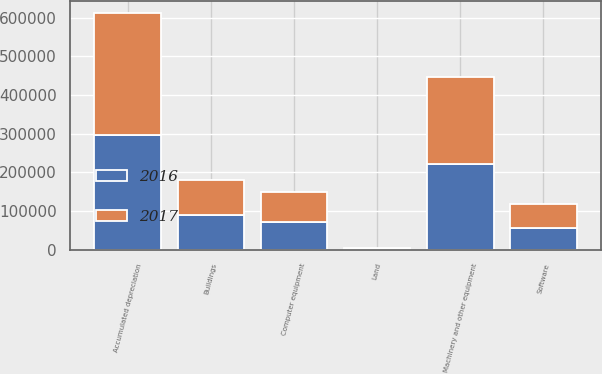Convert chart to OTSL. <chart><loc_0><loc_0><loc_500><loc_500><stacked_bar_chart><ecel><fcel>Land<fcel>Buildings<fcel>Machinery and other equipment<fcel>Computer equipment<fcel>Software<fcel>Accumulated depreciation<nl><fcel>2017<fcel>2471<fcel>90683<fcel>226320<fcel>77508<fcel>62387<fcel>316834<nl><fcel>2016<fcel>2404<fcel>88201<fcel>221325<fcel>70110<fcel>54451<fcel>295173<nl></chart> 